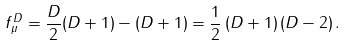<formula> <loc_0><loc_0><loc_500><loc_500>f _ { \mu } ^ { D } = \frac { D } { 2 } ( D + 1 ) - ( D + 1 ) = \frac { 1 } { 2 } \left ( D + 1 \right ) \left ( D - 2 \right ) .</formula> 